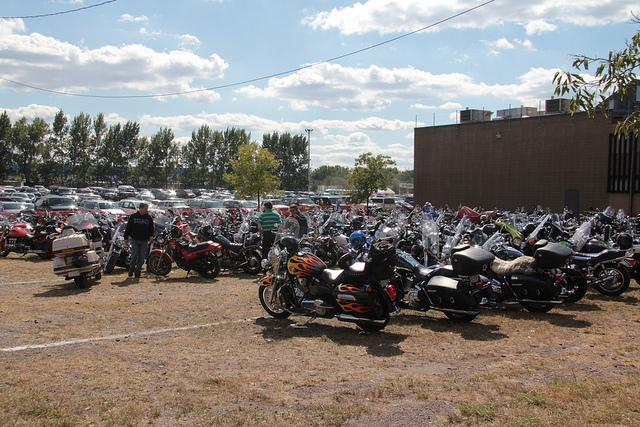The glare from the sun is distracting for drivers by reflecting off of what surface? Please explain your reasoning. motorcycle shields. The shield is right in front of the drivers face and would be the most distracting spot for a reflection. 